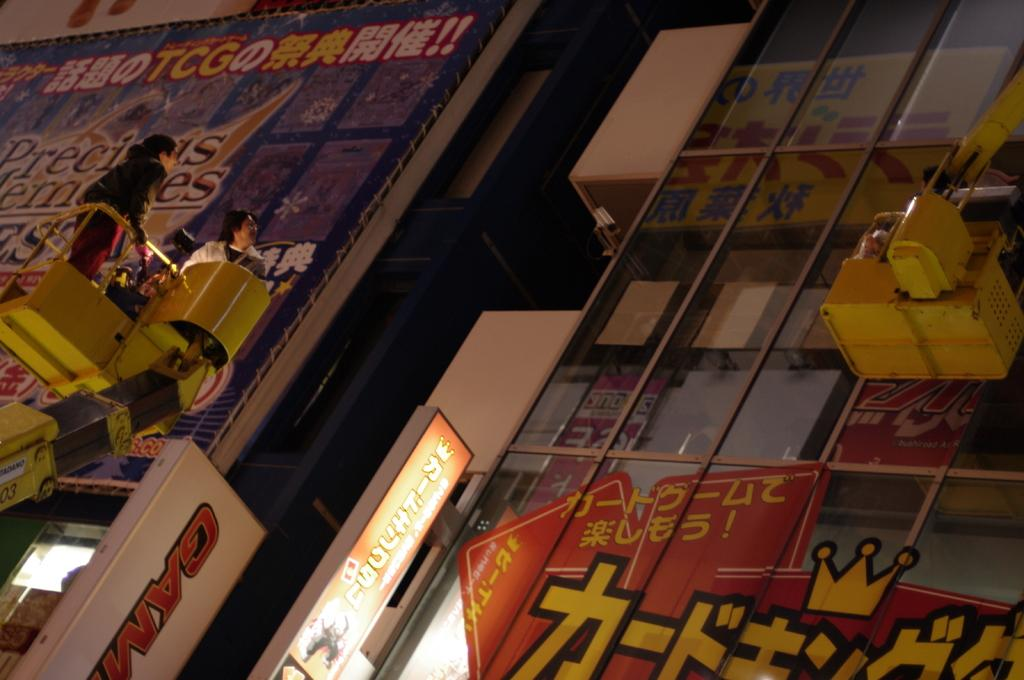<image>
Share a concise interpretation of the image provided. windows with chinese writing an the letters TCG in yellow in the upper left 